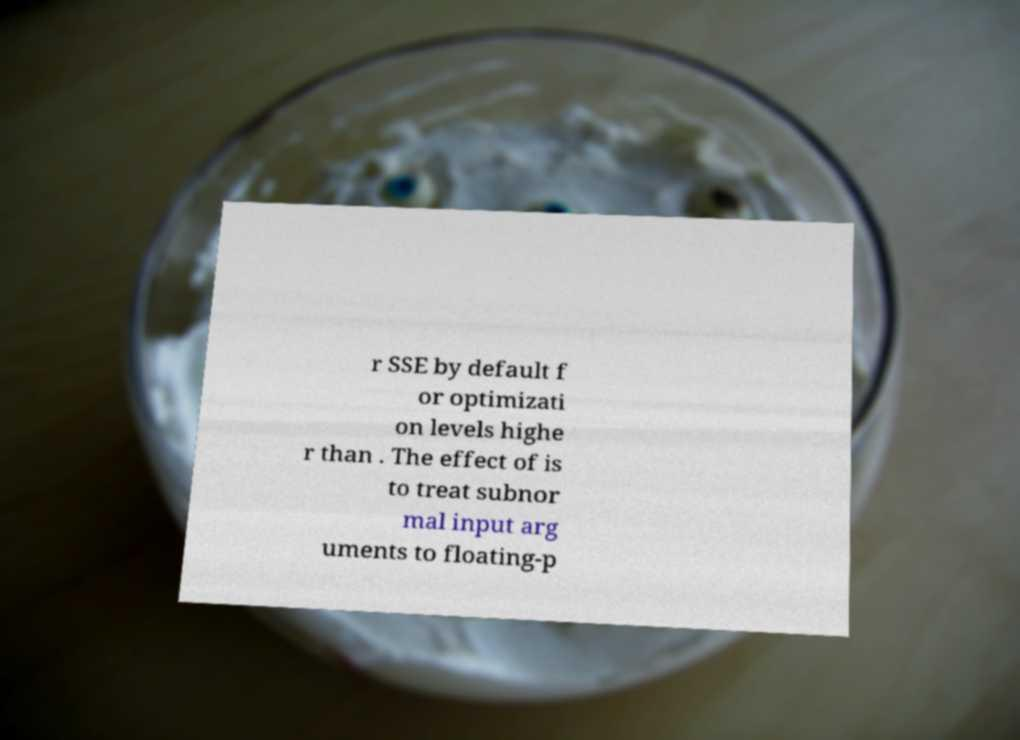Could you assist in decoding the text presented in this image and type it out clearly? r SSE by default f or optimizati on levels highe r than . The effect of is to treat subnor mal input arg uments to floating-p 